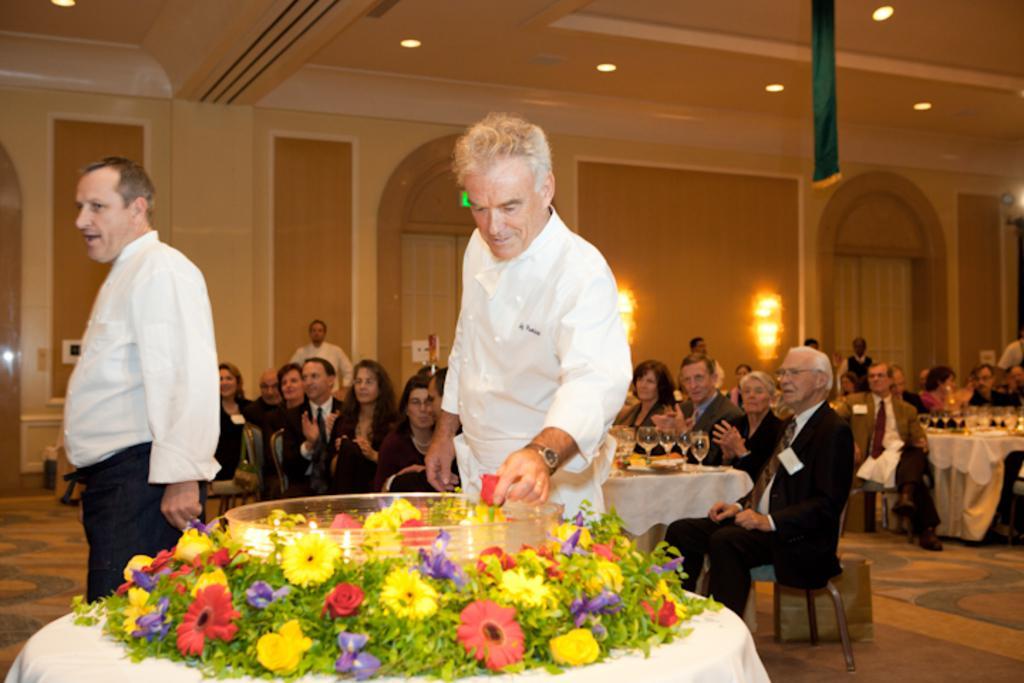Describe this image in one or two sentences. In the image we can see there are two people standing, wearing clothes, this is a wristwatch, flower, table, chair, wine glass, there are even other people sitting on a chair, this is a floor, light, on the table there are food items. This is a switchboard. 